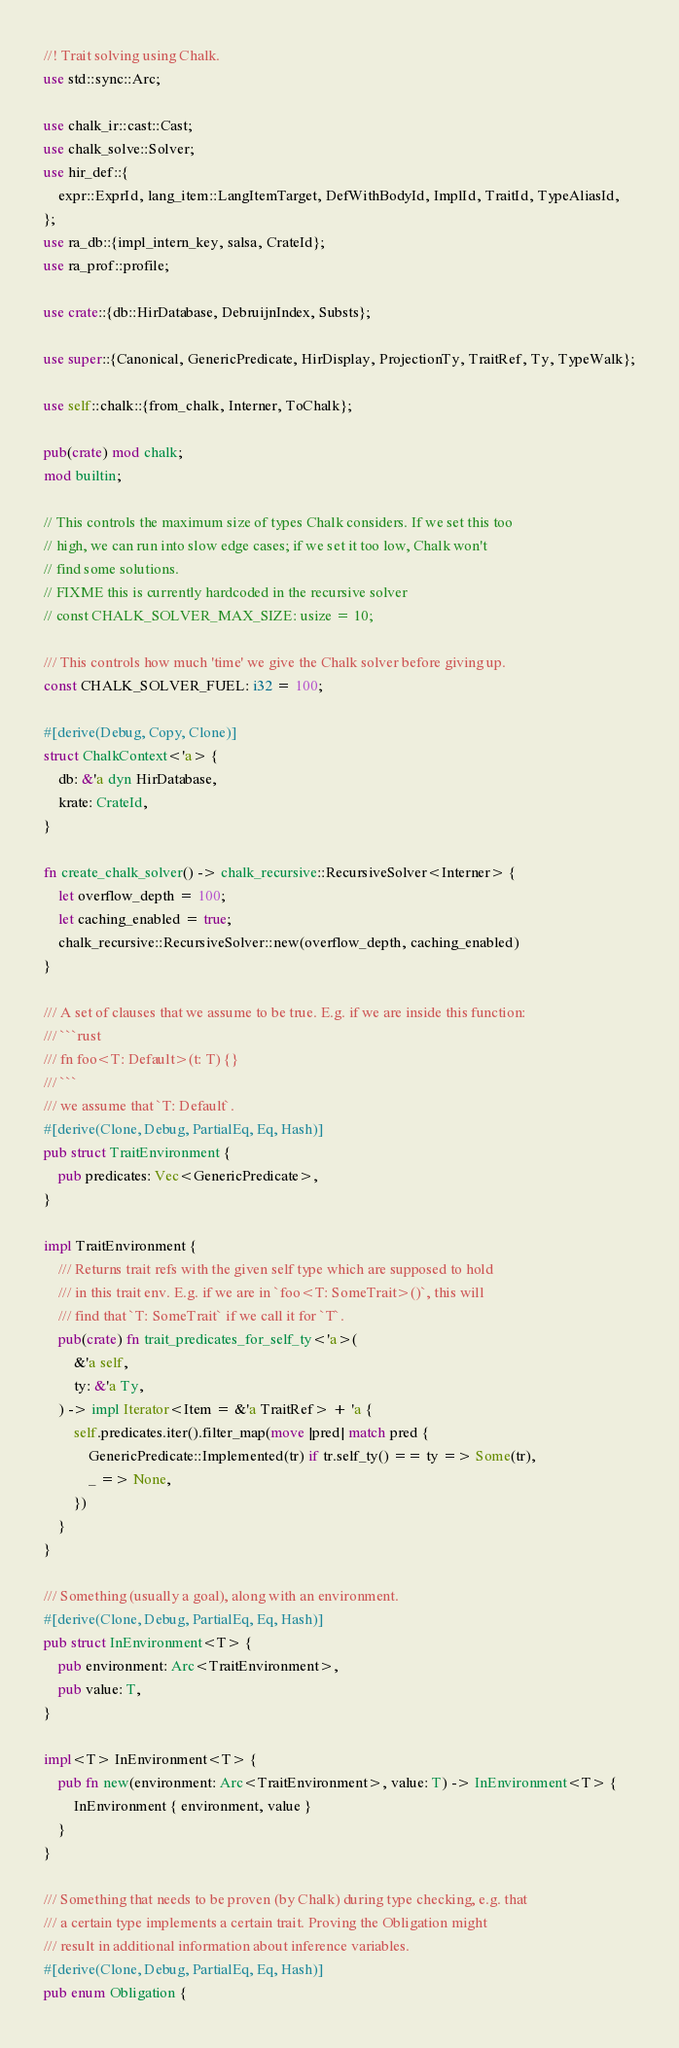Convert code to text. <code><loc_0><loc_0><loc_500><loc_500><_Rust_>//! Trait solving using Chalk.
use std::sync::Arc;

use chalk_ir::cast::Cast;
use chalk_solve::Solver;
use hir_def::{
    expr::ExprId, lang_item::LangItemTarget, DefWithBodyId, ImplId, TraitId, TypeAliasId,
};
use ra_db::{impl_intern_key, salsa, CrateId};
use ra_prof::profile;

use crate::{db::HirDatabase, DebruijnIndex, Substs};

use super::{Canonical, GenericPredicate, HirDisplay, ProjectionTy, TraitRef, Ty, TypeWalk};

use self::chalk::{from_chalk, Interner, ToChalk};

pub(crate) mod chalk;
mod builtin;

// This controls the maximum size of types Chalk considers. If we set this too
// high, we can run into slow edge cases; if we set it too low, Chalk won't
// find some solutions.
// FIXME this is currently hardcoded in the recursive solver
// const CHALK_SOLVER_MAX_SIZE: usize = 10;

/// This controls how much 'time' we give the Chalk solver before giving up.
const CHALK_SOLVER_FUEL: i32 = 100;

#[derive(Debug, Copy, Clone)]
struct ChalkContext<'a> {
    db: &'a dyn HirDatabase,
    krate: CrateId,
}

fn create_chalk_solver() -> chalk_recursive::RecursiveSolver<Interner> {
    let overflow_depth = 100;
    let caching_enabled = true;
    chalk_recursive::RecursiveSolver::new(overflow_depth, caching_enabled)
}

/// A set of clauses that we assume to be true. E.g. if we are inside this function:
/// ```rust
/// fn foo<T: Default>(t: T) {}
/// ```
/// we assume that `T: Default`.
#[derive(Clone, Debug, PartialEq, Eq, Hash)]
pub struct TraitEnvironment {
    pub predicates: Vec<GenericPredicate>,
}

impl TraitEnvironment {
    /// Returns trait refs with the given self type which are supposed to hold
    /// in this trait env. E.g. if we are in `foo<T: SomeTrait>()`, this will
    /// find that `T: SomeTrait` if we call it for `T`.
    pub(crate) fn trait_predicates_for_self_ty<'a>(
        &'a self,
        ty: &'a Ty,
    ) -> impl Iterator<Item = &'a TraitRef> + 'a {
        self.predicates.iter().filter_map(move |pred| match pred {
            GenericPredicate::Implemented(tr) if tr.self_ty() == ty => Some(tr),
            _ => None,
        })
    }
}

/// Something (usually a goal), along with an environment.
#[derive(Clone, Debug, PartialEq, Eq, Hash)]
pub struct InEnvironment<T> {
    pub environment: Arc<TraitEnvironment>,
    pub value: T,
}

impl<T> InEnvironment<T> {
    pub fn new(environment: Arc<TraitEnvironment>, value: T) -> InEnvironment<T> {
        InEnvironment { environment, value }
    }
}

/// Something that needs to be proven (by Chalk) during type checking, e.g. that
/// a certain type implements a certain trait. Proving the Obligation might
/// result in additional information about inference variables.
#[derive(Clone, Debug, PartialEq, Eq, Hash)]
pub enum Obligation {</code> 